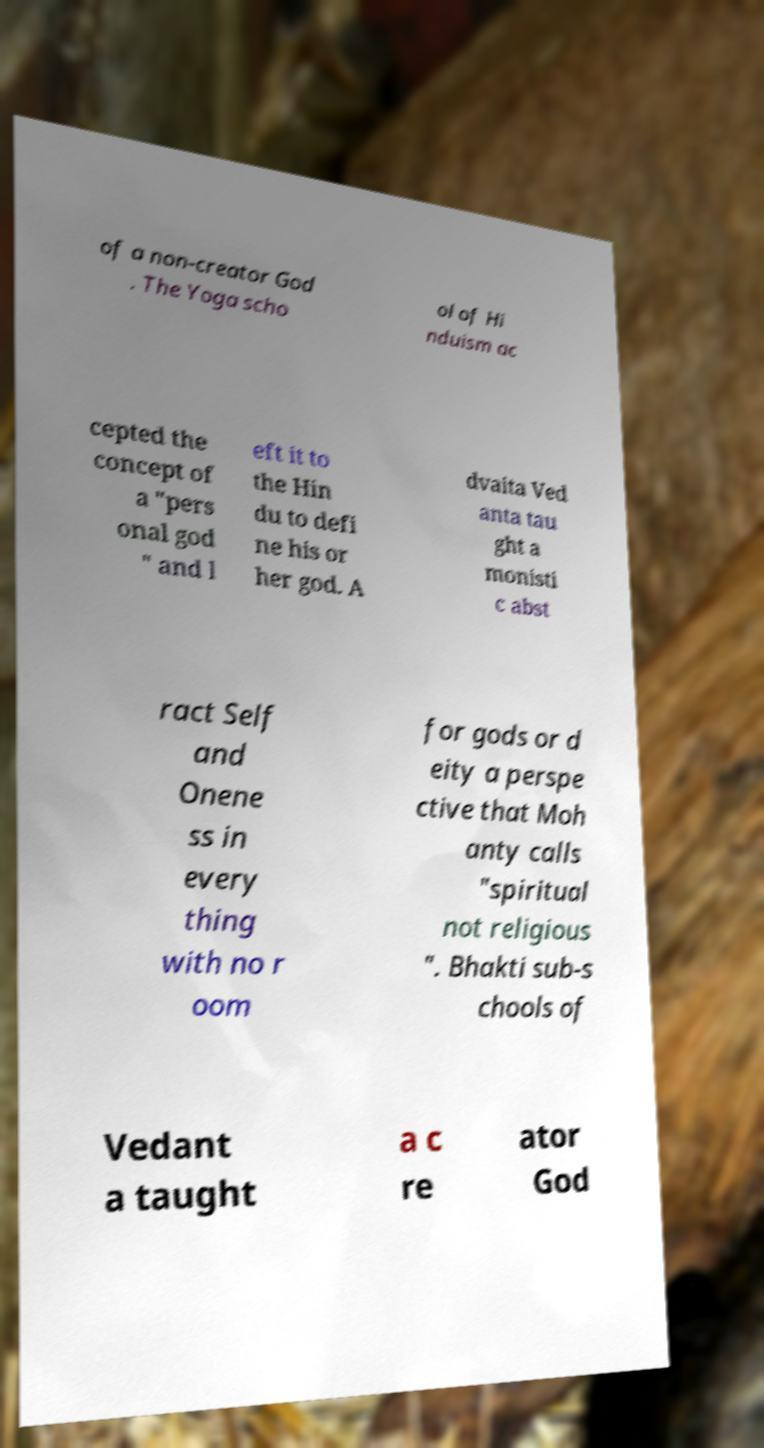Please identify and transcribe the text found in this image. of a non-creator God . The Yoga scho ol of Hi nduism ac cepted the concept of a "pers onal god " and l eft it to the Hin du to defi ne his or her god. A dvaita Ved anta tau ght a monisti c abst ract Self and Onene ss in every thing with no r oom for gods or d eity a perspe ctive that Moh anty calls "spiritual not religious ". Bhakti sub-s chools of Vedant a taught a c re ator God 